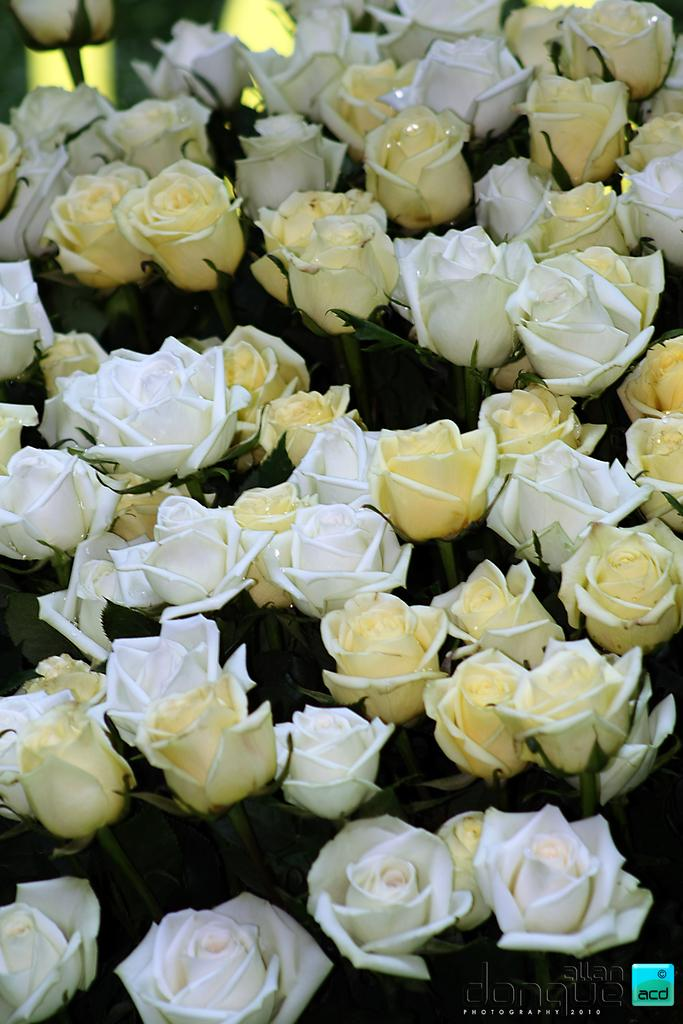What type of living organisms can be seen in the image? There are flowers in the image. Where is the text located in the image? The text is in the bottom right corner of the image. What is also present in the bottom right corner of the image? There is a logo in the bottom right corner of the image. Can you see any mice playing in the sand in the image? There are no mice or sand present in the image; it features flowers and text with a logo. 